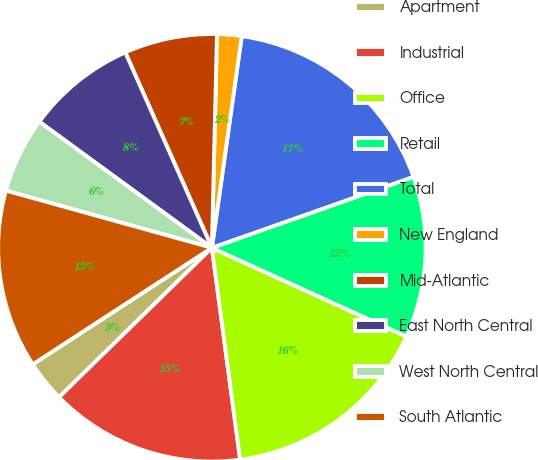Convert chart to OTSL. <chart><loc_0><loc_0><loc_500><loc_500><pie_chart><fcel>Apartment<fcel>Industrial<fcel>Office<fcel>Retail<fcel>Total<fcel>New England<fcel>Mid-Atlantic<fcel>East North Central<fcel>West North Central<fcel>South Atlantic<nl><fcel>3.14%<fcel>14.79%<fcel>16.08%<fcel>12.2%<fcel>17.38%<fcel>1.85%<fcel>7.02%<fcel>8.32%<fcel>5.73%<fcel>13.49%<nl></chart> 